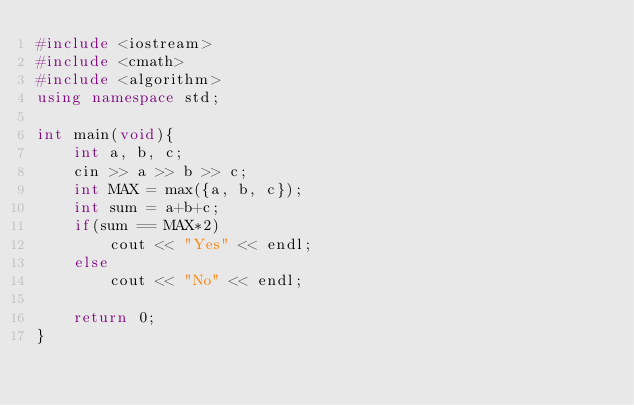Convert code to text. <code><loc_0><loc_0><loc_500><loc_500><_C++_>#include <iostream>
#include <cmath>
#include <algorithm>
using namespace std;

int main(void){
    int a, b, c;
    cin >> a >> b >> c;
    int MAX = max({a, b, c});
    int sum = a+b+c;
    if(sum == MAX*2)
        cout << "Yes" << endl;
    else
        cout << "No" << endl;
    
    return 0;
}</code> 